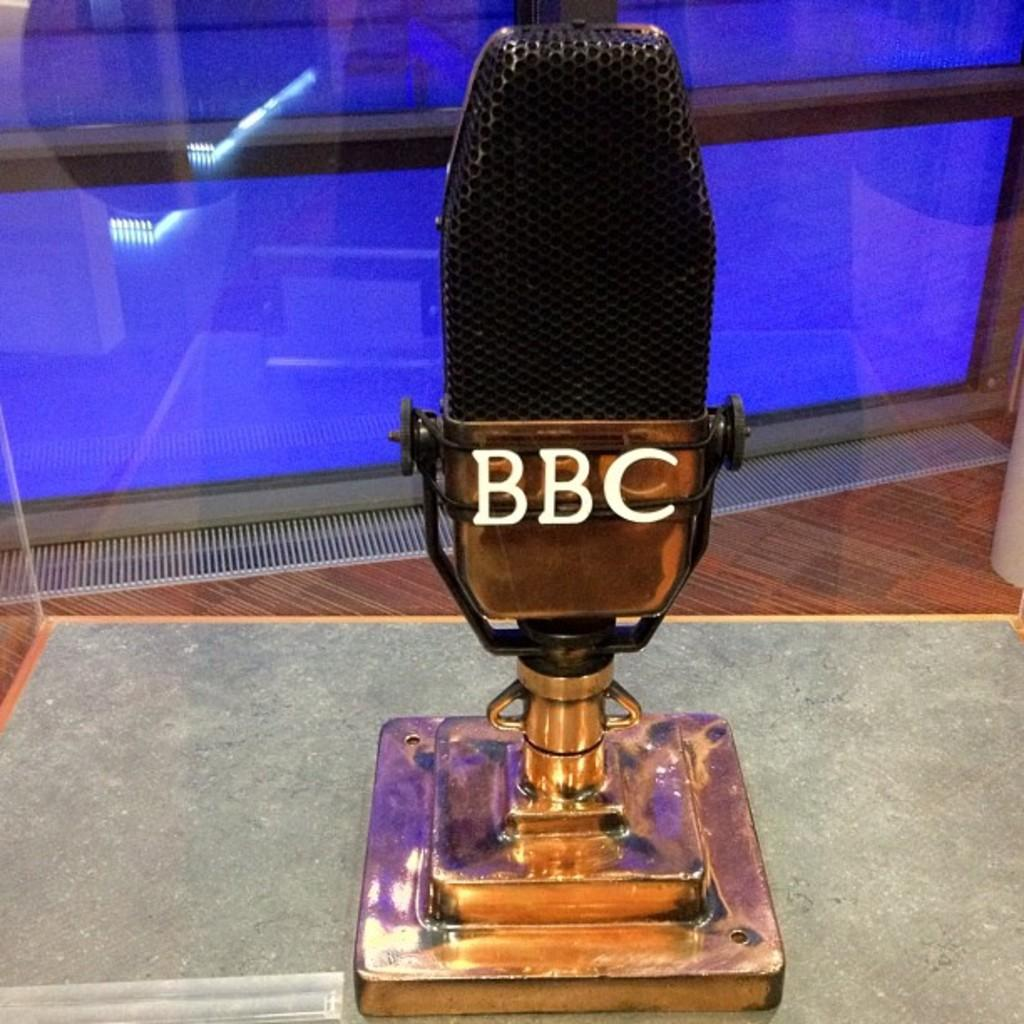What is the main object in the image? There is a mile in the image. Where is the mile located? The mile is placed on a table. What can be found on the mile? There is text on the mile. What else can be seen in the background of the image? There is a glass in the background of the image. What angle does the society take in the image? There is no reference to a society or any angles in the image, as it features a mile placed on a table with text and a glass in the background. 